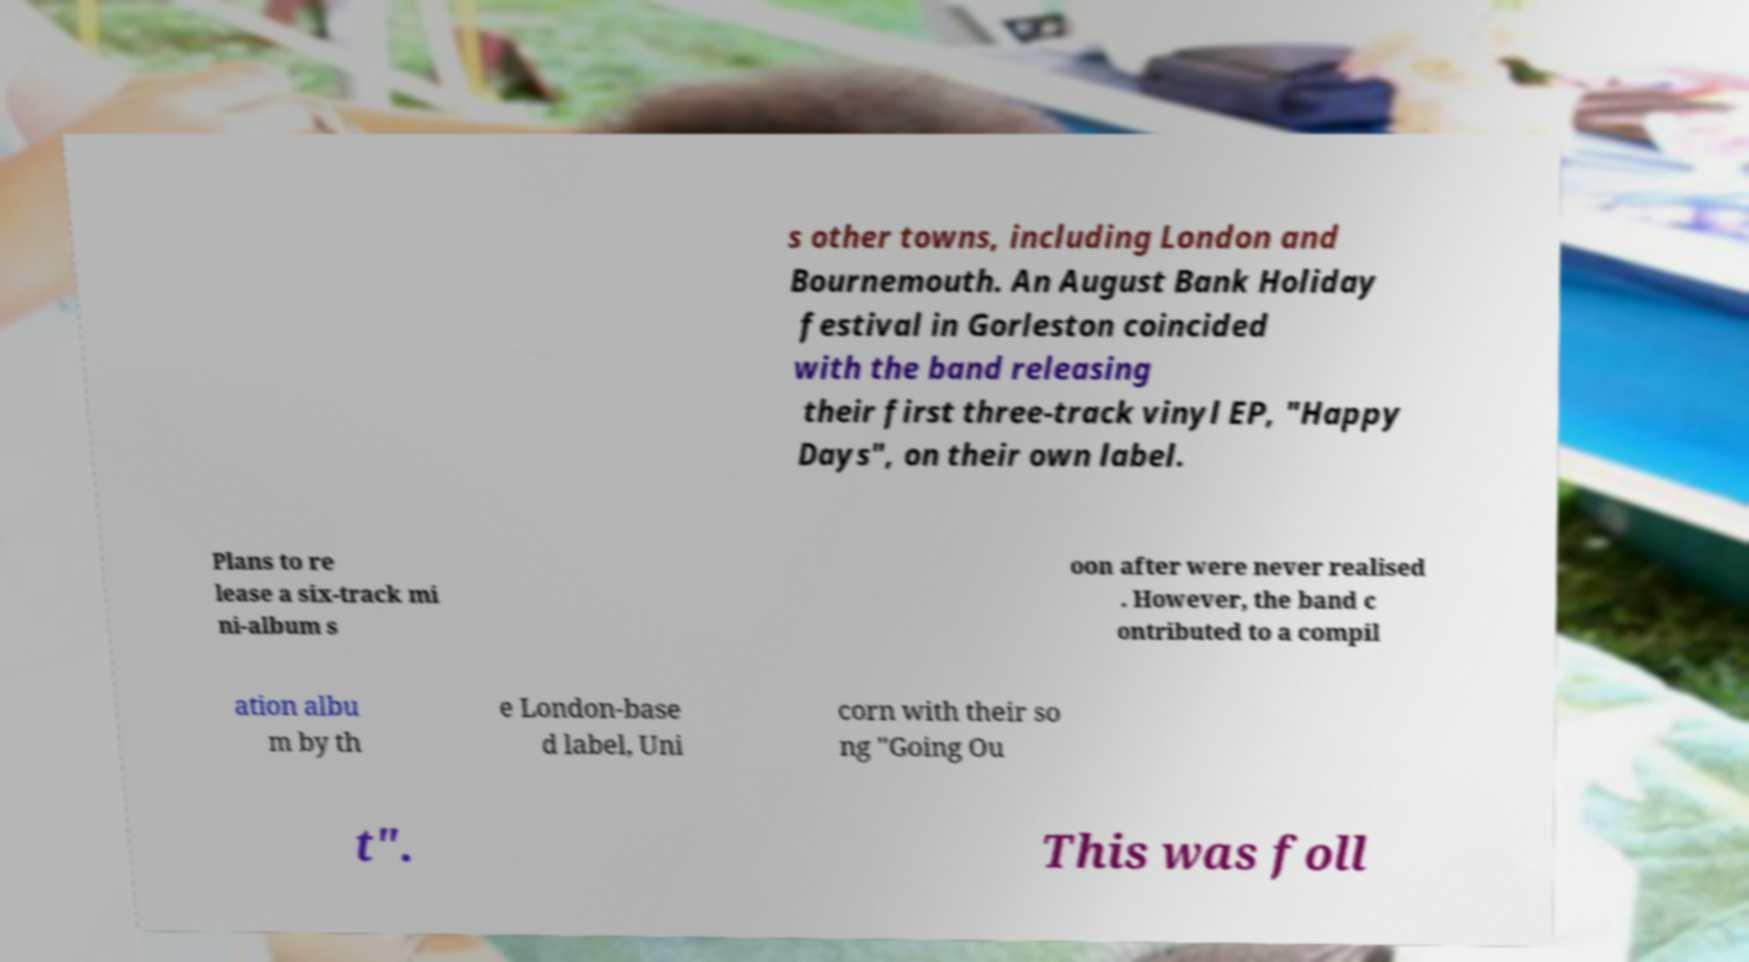Can you read and provide the text displayed in the image?This photo seems to have some interesting text. Can you extract and type it out for me? s other towns, including London and Bournemouth. An August Bank Holiday festival in Gorleston coincided with the band releasing their first three-track vinyl EP, "Happy Days", on their own label. Plans to re lease a six-track mi ni-album s oon after were never realised . However, the band c ontributed to a compil ation albu m by th e London-base d label, Uni corn with their so ng "Going Ou t". This was foll 